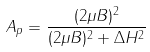Convert formula to latex. <formula><loc_0><loc_0><loc_500><loc_500>A _ { p } = \frac { ( 2 \mu B ) ^ { 2 } } { ( 2 \mu B ) ^ { 2 } + \Delta H ^ { 2 } }</formula> 